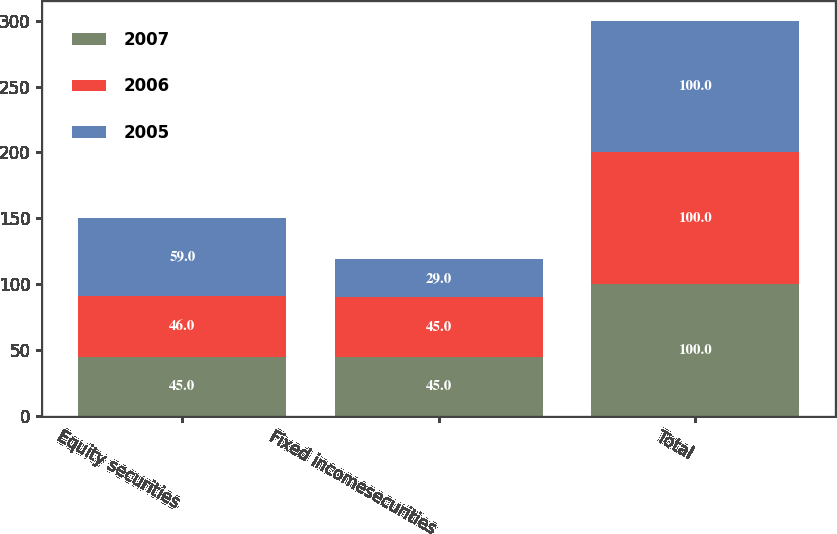Convert chart. <chart><loc_0><loc_0><loc_500><loc_500><stacked_bar_chart><ecel><fcel>Equity securities<fcel>Fixed incomesecurities<fcel>Total<nl><fcel>2007<fcel>45<fcel>45<fcel>100<nl><fcel>2006<fcel>46<fcel>45<fcel>100<nl><fcel>2005<fcel>59<fcel>29<fcel>100<nl></chart> 